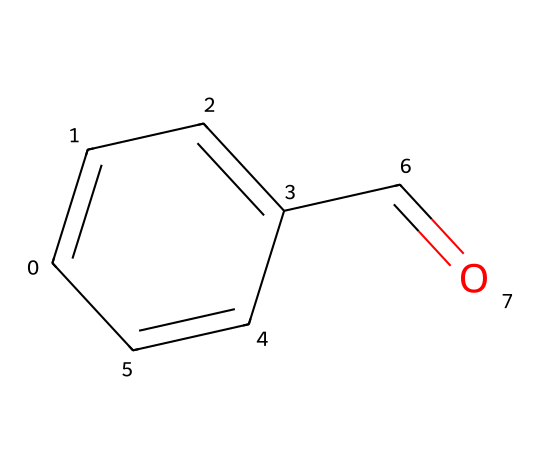How many carbon atoms are present in benzaldehyde? The SMILES representation shows a total of six carbon atoms (C) in the structure. This can be counted by identifying each 'C' in the SMILES string "C1=CC=C(C=C1)C=O" which indicates a benzene ring structure along with one additional carbon in the form of a carbonyl group (C=O).
Answer: six What type of functional group is present in benzaldehyde? The presence of the carbonyl group (C=O) at the end of the structure indicates that benzaldehyde contains an aldehyde functional group. Aldehydes are characterized by having a carbonyl group attached to at least one hydrogen atom.
Answer: aldehyde How many double bonds are there in the structure of benzaldehyde? The SMILES representation of benzaldehyde includes four double bonds, which can be determined by recognizing both the double bonds in the aromatic ring (represented by the '=' characters) and the double bond in the carbonyl group (C=O).
Answer: four What is the primary scent associated with benzaldehyde? Benzaldehyde is often recognized for its characteristic almond scent, which arises from its use in flavoring and fragrance applications. This aroma is specifically linked to the structure of benzaldehyde as it is naturally found in almonds and cherry pits.
Answer: almond What is the molecular formula of benzaldehyde? From the SMILES representation, we can derive the molecular formula by summarizing the counts of each atom: 6 carbons (C), 5 hydrogens (H), and 1 oxygen (O). Therefore, the molecular formula of benzaldehyde can be written as C6H5O.
Answer: C6H5O What is the structural feature that distinguishes benzaldehyde from other aromatic compounds? The key distinguishing feature of benzaldehyde is the aldehyde group at the end of the aromatic ring, which is not found in aromatic compounds that contain only hydroxyl, alkyl, or other substituents. The carbonyl (C=O) is unique to aldehydes among typical aromatic compounds.
Answer: aldehyde group What property makes benzaldehyde useful in flavors and fragrances? The ability of benzaldehyde to impart a sweet, almond-like scent makes it highly desirable in the formulation of flavors and fragrances, appealing to its aromatic profile that adds a distinct character to various products.
Answer: sweet almond scent 